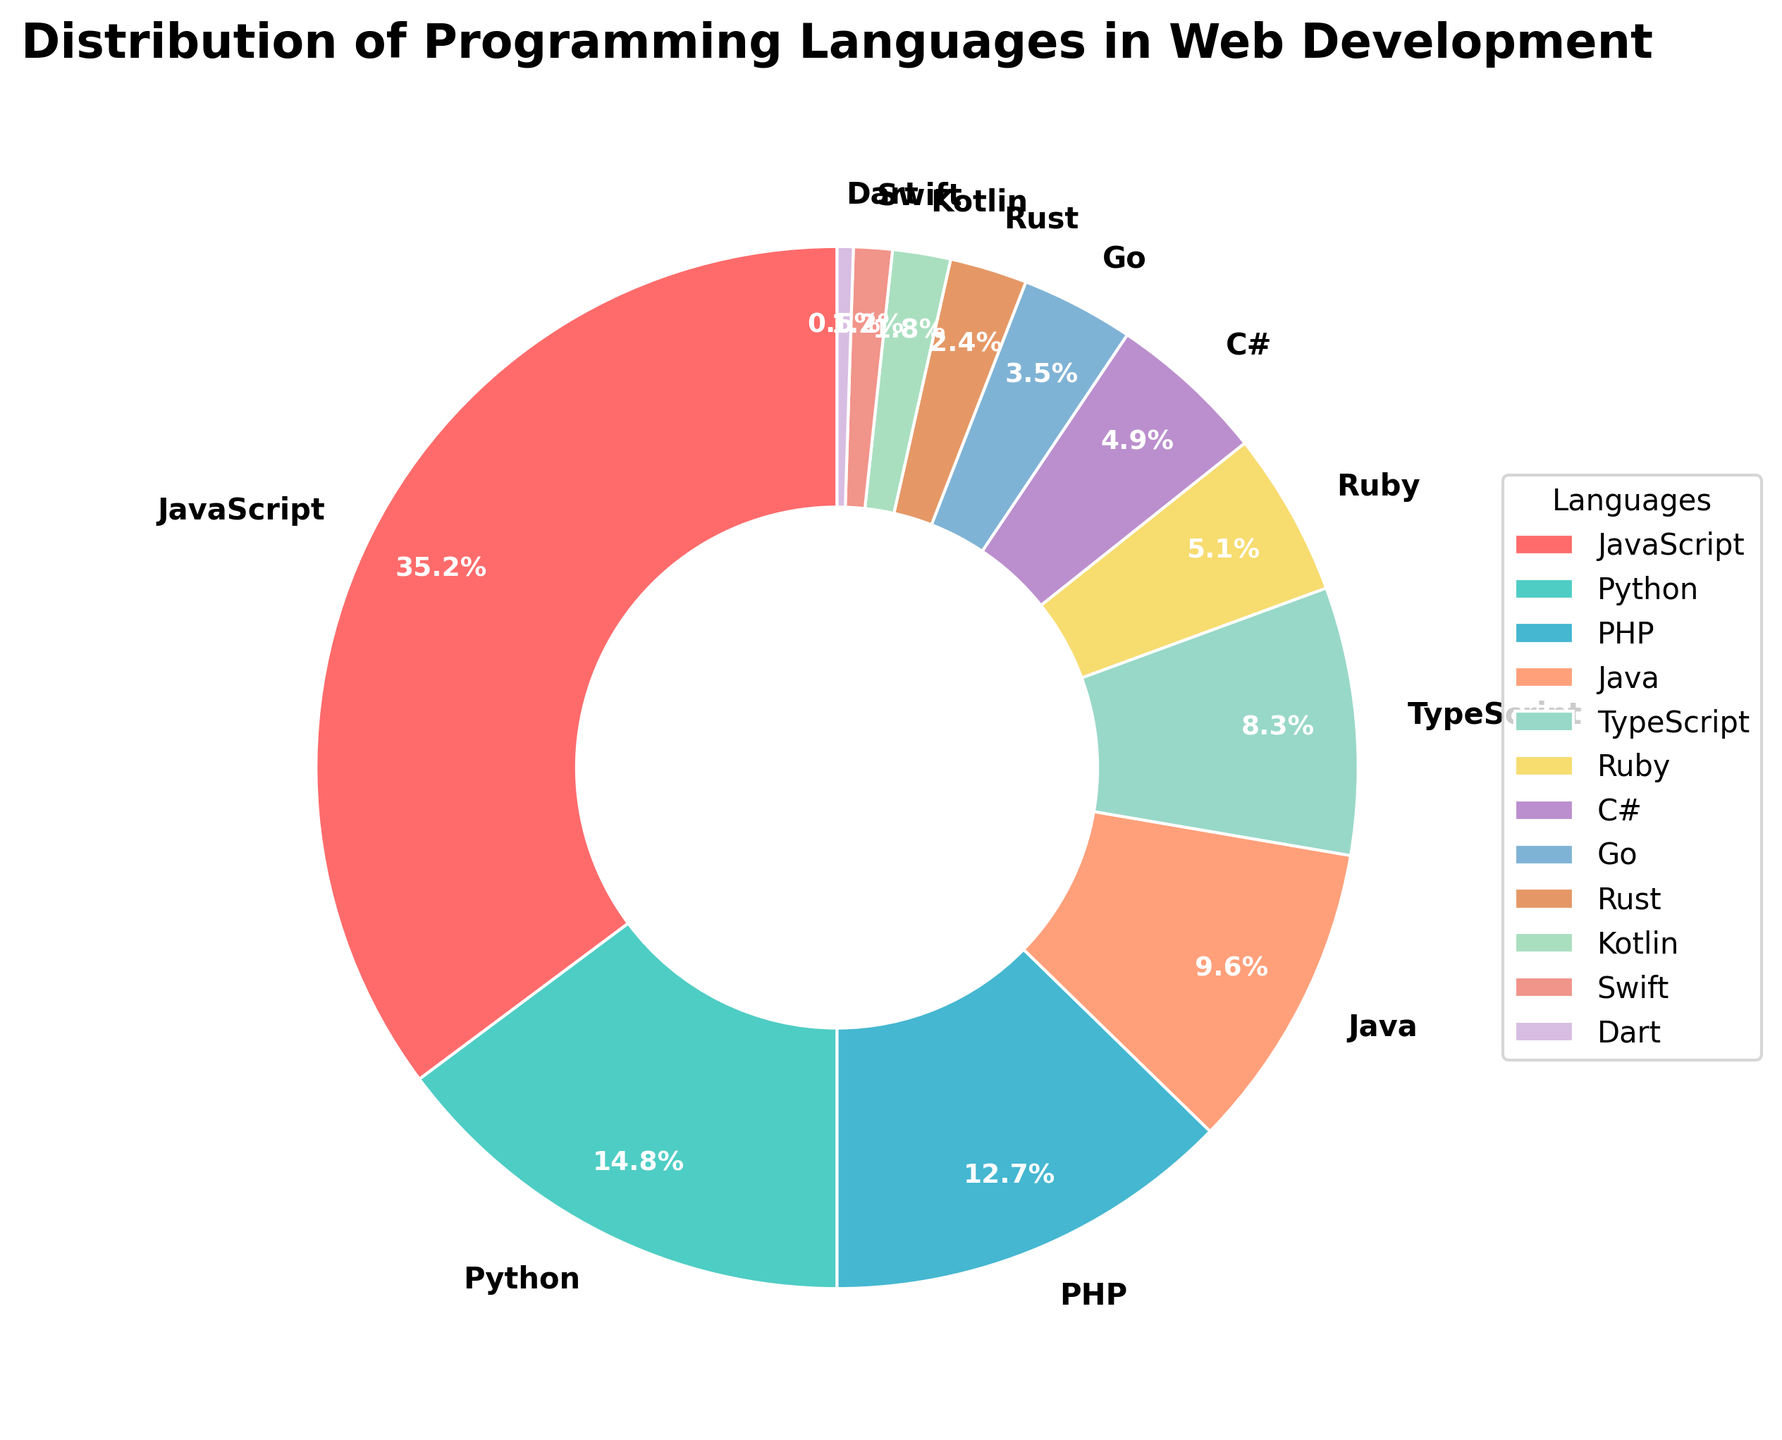What is the most used programming language in web development according to the figure? The largest portion of the pie chart represents the most used programming language. By examining the largest section, we see that JavaScript occupies 35.2% of the total distribution, making it the most used language.
Answer: JavaScript Which programming language has the smallest usage in web development? The smallest section in the pie chart corresponds to Dart, which occupies the smallest percentage of 0.5%.
Answer: Dart How much more percentage does JavaScript have compared to Python in web development? JavaScript has 35.2% whereas Python has 14.8%. Calculate the difference: 35.2 - 14.8 = 20.4
Answer: 20.4 What is the combined percentage of PHP and Java? PHP has 12.7% and Java has 9.6%. Adding them together: 12.7 + 9.6 = 22.3%
Answer: 22.3% Which language group (TypeScript and Ruby) or (C# and Go) has more use in web development? TypeScript has 8.3% and Ruby has 5.1%, combined they have: 8.3 + 5.1 = 13.4%. C# has 4.9% and Go has 3.5%, combined they have: 4.9 + 3.5 = 8.4%. By comparing the two sums, 13.4% > 8.4%, hence the languages TypeScript and Ruby have more use.
Answer: TypeScript and Ruby Which color represents Python? The colors representing each segment are ordered from the largest to smallest percentage. Considering the order and using the color mapping provided (JavaScript: red, Python: green, etc), the second segment representing 14.8% is green.
Answer: Green What percentage of usage do all languages except JavaScript account for? Subtract the percentage of JavaScript from 100% to find the combined percentage of all other languages: 100 - 35.2 = 64.8%
Answer: 64.8% By how much does Rust exceed Kotlin in terms of percentage usage? Rust has 2.4% and Kotlin has 1.8%. Subtracting the percentage of Kotlin from Rust: 2.4 - 1.8 = 0.6%
Answer: 0.6% What is the average percentage use of the top three most used programming languages? The top three languages by percentage are JavaScript (35.2%), Python (14.8%), and PHP (12.7%). Calculate the average: (35.2 + 14.8 + 12.7) / 3 ≈ 20.9%
Answer: 20.9% Which language has a higher usage, Go or Swift? Referring to the chart, Go has 3.5% while Swift has 1.2%. By comparison, 3.5% is greater than 1.2%, thus Go has a higher usage.
Answer: Go 